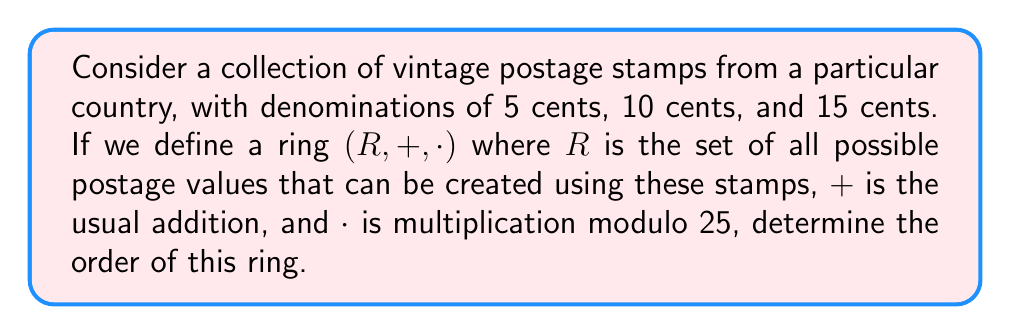Help me with this question. To solve this problem, we need to follow these steps:

1) First, we need to determine the elements of the ring $R$. The possible postage values are linear combinations of 5, 10, and 15 cents, modulo 25 (since the multiplication operation is defined modulo 25).

   $R = \{0, 5, 10, 15, 20\}$

   This is because:
   - 0 = 25 ≡ 0 (mod 25)
   - 5 ≡ 5 (mod 25)
   - 10 ≡ 10 (mod 25)
   - 15 ≡ 15 (mod 25)
   - 20 ≡ 20 (mod 25)
   - 25 ≡ 0 (mod 25)

2) The addition operation $+$ is closed in $R$, as any sum of elements in $R$ will still be in $R$ (mod 25).

3) The multiplication operation $\cdot$ is also closed in $R$, as any product of elements in $R$ will still be in $R$ (mod 25).

4) The ring has an identity element for addition (0) and multiplication (1 ≡ 1 (mod 25)).

5) The order of a ring is the number of elements in the set $R$.

Therefore, the order of the ring is the number of elements in the set $R$, which is 5.
Answer: The order of the ring is 5. 